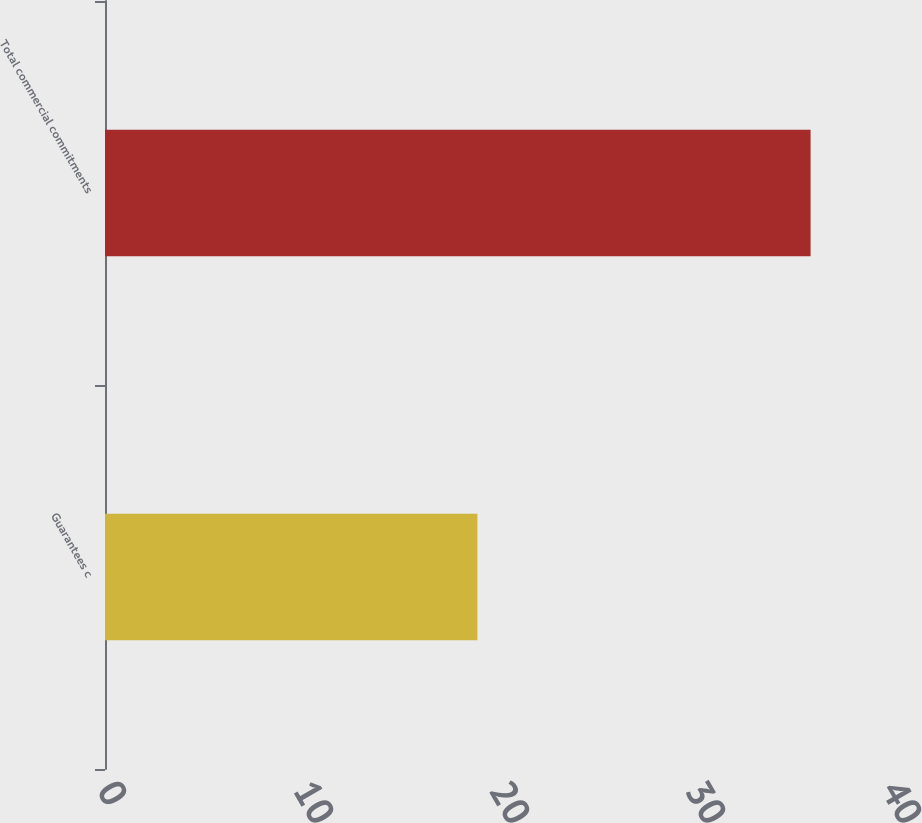Convert chart to OTSL. <chart><loc_0><loc_0><loc_500><loc_500><bar_chart><fcel>Guarantees c<fcel>Total commercial commitments<nl><fcel>19<fcel>36<nl></chart> 